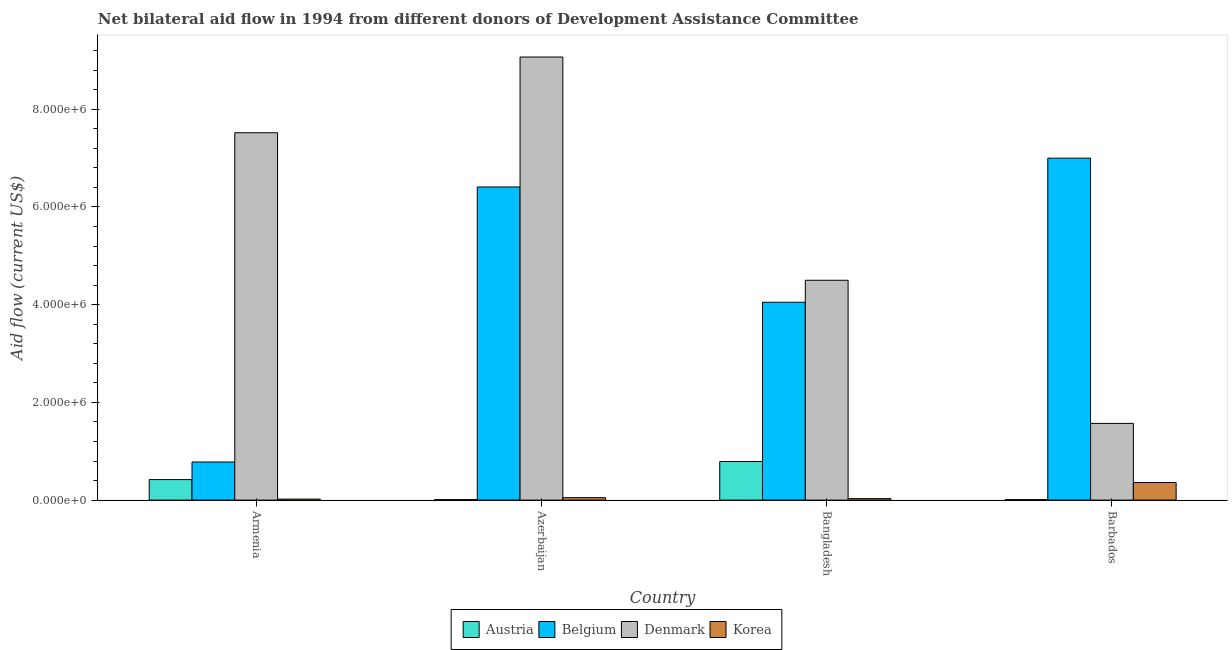How many bars are there on the 4th tick from the left?
Offer a terse response. 4. What is the amount of aid given by denmark in Azerbaijan?
Your response must be concise. 9.07e+06. Across all countries, what is the maximum amount of aid given by belgium?
Your answer should be very brief. 7.00e+06. Across all countries, what is the minimum amount of aid given by belgium?
Provide a succinct answer. 7.80e+05. In which country was the amount of aid given by denmark maximum?
Give a very brief answer. Azerbaijan. In which country was the amount of aid given by korea minimum?
Ensure brevity in your answer.  Armenia. What is the total amount of aid given by korea in the graph?
Keep it short and to the point. 4.60e+05. What is the difference between the amount of aid given by austria in Armenia and that in Azerbaijan?
Your answer should be very brief. 4.10e+05. What is the difference between the amount of aid given by belgium in Bangladesh and the amount of aid given by denmark in Barbados?
Your response must be concise. 2.48e+06. What is the average amount of aid given by denmark per country?
Offer a terse response. 5.66e+06. What is the difference between the amount of aid given by austria and amount of aid given by korea in Bangladesh?
Make the answer very short. 7.60e+05. What is the ratio of the amount of aid given by korea in Azerbaijan to that in Barbados?
Provide a succinct answer. 0.14. Is the amount of aid given by denmark in Armenia less than that in Bangladesh?
Offer a very short reply. No. What is the difference between the highest and the second highest amount of aid given by denmark?
Ensure brevity in your answer.  1.55e+06. What is the difference between the highest and the lowest amount of aid given by belgium?
Your response must be concise. 6.22e+06. In how many countries, is the amount of aid given by korea greater than the average amount of aid given by korea taken over all countries?
Keep it short and to the point. 1. Is the sum of the amount of aid given by denmark in Armenia and Barbados greater than the maximum amount of aid given by belgium across all countries?
Offer a terse response. Yes. Is it the case that in every country, the sum of the amount of aid given by austria and amount of aid given by denmark is greater than the sum of amount of aid given by belgium and amount of aid given by korea?
Keep it short and to the point. Yes. What does the 3rd bar from the left in Azerbaijan represents?
Make the answer very short. Denmark. What does the 1st bar from the right in Azerbaijan represents?
Offer a terse response. Korea. Is it the case that in every country, the sum of the amount of aid given by austria and amount of aid given by belgium is greater than the amount of aid given by denmark?
Offer a terse response. No. How many bars are there?
Your answer should be very brief. 16. Are all the bars in the graph horizontal?
Your answer should be very brief. No. Are the values on the major ticks of Y-axis written in scientific E-notation?
Provide a short and direct response. Yes. Does the graph contain any zero values?
Your response must be concise. No. Where does the legend appear in the graph?
Make the answer very short. Bottom center. How many legend labels are there?
Your answer should be very brief. 4. What is the title of the graph?
Offer a very short reply. Net bilateral aid flow in 1994 from different donors of Development Assistance Committee. What is the label or title of the Y-axis?
Provide a short and direct response. Aid flow (current US$). What is the Aid flow (current US$) in Austria in Armenia?
Offer a very short reply. 4.20e+05. What is the Aid flow (current US$) in Belgium in Armenia?
Offer a very short reply. 7.80e+05. What is the Aid flow (current US$) in Denmark in Armenia?
Give a very brief answer. 7.52e+06. What is the Aid flow (current US$) of Korea in Armenia?
Offer a very short reply. 2.00e+04. What is the Aid flow (current US$) in Belgium in Azerbaijan?
Keep it short and to the point. 6.41e+06. What is the Aid flow (current US$) in Denmark in Azerbaijan?
Provide a short and direct response. 9.07e+06. What is the Aid flow (current US$) of Korea in Azerbaijan?
Your answer should be very brief. 5.00e+04. What is the Aid flow (current US$) of Austria in Bangladesh?
Keep it short and to the point. 7.90e+05. What is the Aid flow (current US$) in Belgium in Bangladesh?
Make the answer very short. 4.05e+06. What is the Aid flow (current US$) of Denmark in Bangladesh?
Provide a succinct answer. 4.50e+06. What is the Aid flow (current US$) in Austria in Barbados?
Offer a terse response. 10000. What is the Aid flow (current US$) in Belgium in Barbados?
Ensure brevity in your answer.  7.00e+06. What is the Aid flow (current US$) of Denmark in Barbados?
Your response must be concise. 1.57e+06. Across all countries, what is the maximum Aid flow (current US$) of Austria?
Provide a succinct answer. 7.90e+05. Across all countries, what is the maximum Aid flow (current US$) in Denmark?
Your answer should be compact. 9.07e+06. Across all countries, what is the minimum Aid flow (current US$) in Belgium?
Ensure brevity in your answer.  7.80e+05. Across all countries, what is the minimum Aid flow (current US$) in Denmark?
Ensure brevity in your answer.  1.57e+06. What is the total Aid flow (current US$) of Austria in the graph?
Ensure brevity in your answer.  1.23e+06. What is the total Aid flow (current US$) of Belgium in the graph?
Your response must be concise. 1.82e+07. What is the total Aid flow (current US$) of Denmark in the graph?
Keep it short and to the point. 2.27e+07. What is the total Aid flow (current US$) in Korea in the graph?
Provide a short and direct response. 4.60e+05. What is the difference between the Aid flow (current US$) in Austria in Armenia and that in Azerbaijan?
Give a very brief answer. 4.10e+05. What is the difference between the Aid flow (current US$) in Belgium in Armenia and that in Azerbaijan?
Keep it short and to the point. -5.63e+06. What is the difference between the Aid flow (current US$) of Denmark in Armenia and that in Azerbaijan?
Give a very brief answer. -1.55e+06. What is the difference between the Aid flow (current US$) of Korea in Armenia and that in Azerbaijan?
Your answer should be very brief. -3.00e+04. What is the difference between the Aid flow (current US$) of Austria in Armenia and that in Bangladesh?
Offer a very short reply. -3.70e+05. What is the difference between the Aid flow (current US$) in Belgium in Armenia and that in Bangladesh?
Provide a succinct answer. -3.27e+06. What is the difference between the Aid flow (current US$) in Denmark in Armenia and that in Bangladesh?
Your answer should be very brief. 3.02e+06. What is the difference between the Aid flow (current US$) of Korea in Armenia and that in Bangladesh?
Your answer should be very brief. -10000. What is the difference between the Aid flow (current US$) in Austria in Armenia and that in Barbados?
Provide a succinct answer. 4.10e+05. What is the difference between the Aid flow (current US$) in Belgium in Armenia and that in Barbados?
Make the answer very short. -6.22e+06. What is the difference between the Aid flow (current US$) of Denmark in Armenia and that in Barbados?
Offer a very short reply. 5.95e+06. What is the difference between the Aid flow (current US$) in Austria in Azerbaijan and that in Bangladesh?
Ensure brevity in your answer.  -7.80e+05. What is the difference between the Aid flow (current US$) in Belgium in Azerbaijan and that in Bangladesh?
Offer a very short reply. 2.36e+06. What is the difference between the Aid flow (current US$) of Denmark in Azerbaijan and that in Bangladesh?
Your answer should be very brief. 4.57e+06. What is the difference between the Aid flow (current US$) of Belgium in Azerbaijan and that in Barbados?
Your answer should be compact. -5.90e+05. What is the difference between the Aid flow (current US$) of Denmark in Azerbaijan and that in Barbados?
Offer a terse response. 7.50e+06. What is the difference between the Aid flow (current US$) of Korea in Azerbaijan and that in Barbados?
Provide a short and direct response. -3.10e+05. What is the difference between the Aid flow (current US$) in Austria in Bangladesh and that in Barbados?
Your answer should be compact. 7.80e+05. What is the difference between the Aid flow (current US$) in Belgium in Bangladesh and that in Barbados?
Ensure brevity in your answer.  -2.95e+06. What is the difference between the Aid flow (current US$) of Denmark in Bangladesh and that in Barbados?
Give a very brief answer. 2.93e+06. What is the difference between the Aid flow (current US$) of Korea in Bangladesh and that in Barbados?
Your answer should be very brief. -3.30e+05. What is the difference between the Aid flow (current US$) in Austria in Armenia and the Aid flow (current US$) in Belgium in Azerbaijan?
Offer a very short reply. -5.99e+06. What is the difference between the Aid flow (current US$) in Austria in Armenia and the Aid flow (current US$) in Denmark in Azerbaijan?
Give a very brief answer. -8.65e+06. What is the difference between the Aid flow (current US$) in Belgium in Armenia and the Aid flow (current US$) in Denmark in Azerbaijan?
Provide a succinct answer. -8.29e+06. What is the difference between the Aid flow (current US$) in Belgium in Armenia and the Aid flow (current US$) in Korea in Azerbaijan?
Your response must be concise. 7.30e+05. What is the difference between the Aid flow (current US$) in Denmark in Armenia and the Aid flow (current US$) in Korea in Azerbaijan?
Provide a succinct answer. 7.47e+06. What is the difference between the Aid flow (current US$) in Austria in Armenia and the Aid flow (current US$) in Belgium in Bangladesh?
Provide a short and direct response. -3.63e+06. What is the difference between the Aid flow (current US$) of Austria in Armenia and the Aid flow (current US$) of Denmark in Bangladesh?
Provide a short and direct response. -4.08e+06. What is the difference between the Aid flow (current US$) of Belgium in Armenia and the Aid flow (current US$) of Denmark in Bangladesh?
Your answer should be compact. -3.72e+06. What is the difference between the Aid flow (current US$) of Belgium in Armenia and the Aid flow (current US$) of Korea in Bangladesh?
Offer a terse response. 7.50e+05. What is the difference between the Aid flow (current US$) of Denmark in Armenia and the Aid flow (current US$) of Korea in Bangladesh?
Make the answer very short. 7.49e+06. What is the difference between the Aid flow (current US$) of Austria in Armenia and the Aid flow (current US$) of Belgium in Barbados?
Provide a succinct answer. -6.58e+06. What is the difference between the Aid flow (current US$) of Austria in Armenia and the Aid flow (current US$) of Denmark in Barbados?
Your answer should be very brief. -1.15e+06. What is the difference between the Aid flow (current US$) in Austria in Armenia and the Aid flow (current US$) in Korea in Barbados?
Your answer should be compact. 6.00e+04. What is the difference between the Aid flow (current US$) in Belgium in Armenia and the Aid flow (current US$) in Denmark in Barbados?
Provide a succinct answer. -7.90e+05. What is the difference between the Aid flow (current US$) of Denmark in Armenia and the Aid flow (current US$) of Korea in Barbados?
Make the answer very short. 7.16e+06. What is the difference between the Aid flow (current US$) in Austria in Azerbaijan and the Aid flow (current US$) in Belgium in Bangladesh?
Give a very brief answer. -4.04e+06. What is the difference between the Aid flow (current US$) in Austria in Azerbaijan and the Aid flow (current US$) in Denmark in Bangladesh?
Provide a succinct answer. -4.49e+06. What is the difference between the Aid flow (current US$) in Austria in Azerbaijan and the Aid flow (current US$) in Korea in Bangladesh?
Offer a very short reply. -2.00e+04. What is the difference between the Aid flow (current US$) of Belgium in Azerbaijan and the Aid flow (current US$) of Denmark in Bangladesh?
Your response must be concise. 1.91e+06. What is the difference between the Aid flow (current US$) in Belgium in Azerbaijan and the Aid flow (current US$) in Korea in Bangladesh?
Provide a short and direct response. 6.38e+06. What is the difference between the Aid flow (current US$) in Denmark in Azerbaijan and the Aid flow (current US$) in Korea in Bangladesh?
Give a very brief answer. 9.04e+06. What is the difference between the Aid flow (current US$) in Austria in Azerbaijan and the Aid flow (current US$) in Belgium in Barbados?
Offer a very short reply. -6.99e+06. What is the difference between the Aid flow (current US$) in Austria in Azerbaijan and the Aid flow (current US$) in Denmark in Barbados?
Your answer should be compact. -1.56e+06. What is the difference between the Aid flow (current US$) in Austria in Azerbaijan and the Aid flow (current US$) in Korea in Barbados?
Give a very brief answer. -3.50e+05. What is the difference between the Aid flow (current US$) of Belgium in Azerbaijan and the Aid flow (current US$) of Denmark in Barbados?
Your answer should be compact. 4.84e+06. What is the difference between the Aid flow (current US$) in Belgium in Azerbaijan and the Aid flow (current US$) in Korea in Barbados?
Your answer should be compact. 6.05e+06. What is the difference between the Aid flow (current US$) in Denmark in Azerbaijan and the Aid flow (current US$) in Korea in Barbados?
Provide a short and direct response. 8.71e+06. What is the difference between the Aid flow (current US$) in Austria in Bangladesh and the Aid flow (current US$) in Belgium in Barbados?
Make the answer very short. -6.21e+06. What is the difference between the Aid flow (current US$) in Austria in Bangladesh and the Aid flow (current US$) in Denmark in Barbados?
Keep it short and to the point. -7.80e+05. What is the difference between the Aid flow (current US$) in Austria in Bangladesh and the Aid flow (current US$) in Korea in Barbados?
Your answer should be very brief. 4.30e+05. What is the difference between the Aid flow (current US$) in Belgium in Bangladesh and the Aid flow (current US$) in Denmark in Barbados?
Offer a terse response. 2.48e+06. What is the difference between the Aid flow (current US$) of Belgium in Bangladesh and the Aid flow (current US$) of Korea in Barbados?
Your answer should be compact. 3.69e+06. What is the difference between the Aid flow (current US$) of Denmark in Bangladesh and the Aid flow (current US$) of Korea in Barbados?
Your answer should be very brief. 4.14e+06. What is the average Aid flow (current US$) in Austria per country?
Your answer should be compact. 3.08e+05. What is the average Aid flow (current US$) in Belgium per country?
Keep it short and to the point. 4.56e+06. What is the average Aid flow (current US$) in Denmark per country?
Provide a succinct answer. 5.66e+06. What is the average Aid flow (current US$) in Korea per country?
Your answer should be compact. 1.15e+05. What is the difference between the Aid flow (current US$) in Austria and Aid flow (current US$) in Belgium in Armenia?
Keep it short and to the point. -3.60e+05. What is the difference between the Aid flow (current US$) in Austria and Aid flow (current US$) in Denmark in Armenia?
Your response must be concise. -7.10e+06. What is the difference between the Aid flow (current US$) of Austria and Aid flow (current US$) of Korea in Armenia?
Make the answer very short. 4.00e+05. What is the difference between the Aid flow (current US$) in Belgium and Aid flow (current US$) in Denmark in Armenia?
Keep it short and to the point. -6.74e+06. What is the difference between the Aid flow (current US$) of Belgium and Aid flow (current US$) of Korea in Armenia?
Ensure brevity in your answer.  7.60e+05. What is the difference between the Aid flow (current US$) in Denmark and Aid flow (current US$) in Korea in Armenia?
Your answer should be compact. 7.50e+06. What is the difference between the Aid flow (current US$) in Austria and Aid flow (current US$) in Belgium in Azerbaijan?
Your response must be concise. -6.40e+06. What is the difference between the Aid flow (current US$) of Austria and Aid flow (current US$) of Denmark in Azerbaijan?
Offer a very short reply. -9.06e+06. What is the difference between the Aid flow (current US$) in Belgium and Aid flow (current US$) in Denmark in Azerbaijan?
Give a very brief answer. -2.66e+06. What is the difference between the Aid flow (current US$) of Belgium and Aid flow (current US$) of Korea in Azerbaijan?
Provide a short and direct response. 6.36e+06. What is the difference between the Aid flow (current US$) in Denmark and Aid flow (current US$) in Korea in Azerbaijan?
Offer a terse response. 9.02e+06. What is the difference between the Aid flow (current US$) in Austria and Aid flow (current US$) in Belgium in Bangladesh?
Offer a very short reply. -3.26e+06. What is the difference between the Aid flow (current US$) in Austria and Aid flow (current US$) in Denmark in Bangladesh?
Offer a terse response. -3.71e+06. What is the difference between the Aid flow (current US$) in Austria and Aid flow (current US$) in Korea in Bangladesh?
Make the answer very short. 7.60e+05. What is the difference between the Aid flow (current US$) in Belgium and Aid flow (current US$) in Denmark in Bangladesh?
Offer a terse response. -4.50e+05. What is the difference between the Aid flow (current US$) of Belgium and Aid flow (current US$) of Korea in Bangladesh?
Give a very brief answer. 4.02e+06. What is the difference between the Aid flow (current US$) of Denmark and Aid flow (current US$) of Korea in Bangladesh?
Offer a terse response. 4.47e+06. What is the difference between the Aid flow (current US$) of Austria and Aid flow (current US$) of Belgium in Barbados?
Your answer should be very brief. -6.99e+06. What is the difference between the Aid flow (current US$) in Austria and Aid flow (current US$) in Denmark in Barbados?
Give a very brief answer. -1.56e+06. What is the difference between the Aid flow (current US$) in Austria and Aid flow (current US$) in Korea in Barbados?
Your answer should be compact. -3.50e+05. What is the difference between the Aid flow (current US$) in Belgium and Aid flow (current US$) in Denmark in Barbados?
Provide a succinct answer. 5.43e+06. What is the difference between the Aid flow (current US$) of Belgium and Aid flow (current US$) of Korea in Barbados?
Offer a terse response. 6.64e+06. What is the difference between the Aid flow (current US$) of Denmark and Aid flow (current US$) of Korea in Barbados?
Your answer should be very brief. 1.21e+06. What is the ratio of the Aid flow (current US$) of Austria in Armenia to that in Azerbaijan?
Provide a short and direct response. 42. What is the ratio of the Aid flow (current US$) of Belgium in Armenia to that in Azerbaijan?
Offer a terse response. 0.12. What is the ratio of the Aid flow (current US$) of Denmark in Armenia to that in Azerbaijan?
Keep it short and to the point. 0.83. What is the ratio of the Aid flow (current US$) in Korea in Armenia to that in Azerbaijan?
Your answer should be compact. 0.4. What is the ratio of the Aid flow (current US$) in Austria in Armenia to that in Bangladesh?
Offer a very short reply. 0.53. What is the ratio of the Aid flow (current US$) of Belgium in Armenia to that in Bangladesh?
Your response must be concise. 0.19. What is the ratio of the Aid flow (current US$) of Denmark in Armenia to that in Bangladesh?
Provide a succinct answer. 1.67. What is the ratio of the Aid flow (current US$) in Korea in Armenia to that in Bangladesh?
Your response must be concise. 0.67. What is the ratio of the Aid flow (current US$) of Belgium in Armenia to that in Barbados?
Your answer should be compact. 0.11. What is the ratio of the Aid flow (current US$) of Denmark in Armenia to that in Barbados?
Your response must be concise. 4.79. What is the ratio of the Aid flow (current US$) in Korea in Armenia to that in Barbados?
Make the answer very short. 0.06. What is the ratio of the Aid flow (current US$) of Austria in Azerbaijan to that in Bangladesh?
Keep it short and to the point. 0.01. What is the ratio of the Aid flow (current US$) of Belgium in Azerbaijan to that in Bangladesh?
Keep it short and to the point. 1.58. What is the ratio of the Aid flow (current US$) of Denmark in Azerbaijan to that in Bangladesh?
Ensure brevity in your answer.  2.02. What is the ratio of the Aid flow (current US$) in Austria in Azerbaijan to that in Barbados?
Offer a very short reply. 1. What is the ratio of the Aid flow (current US$) of Belgium in Azerbaijan to that in Barbados?
Offer a terse response. 0.92. What is the ratio of the Aid flow (current US$) in Denmark in Azerbaijan to that in Barbados?
Your answer should be compact. 5.78. What is the ratio of the Aid flow (current US$) in Korea in Azerbaijan to that in Barbados?
Offer a terse response. 0.14. What is the ratio of the Aid flow (current US$) of Austria in Bangladesh to that in Barbados?
Provide a short and direct response. 79. What is the ratio of the Aid flow (current US$) of Belgium in Bangladesh to that in Barbados?
Your response must be concise. 0.58. What is the ratio of the Aid flow (current US$) in Denmark in Bangladesh to that in Barbados?
Your answer should be compact. 2.87. What is the ratio of the Aid flow (current US$) in Korea in Bangladesh to that in Barbados?
Your answer should be compact. 0.08. What is the difference between the highest and the second highest Aid flow (current US$) of Austria?
Your response must be concise. 3.70e+05. What is the difference between the highest and the second highest Aid flow (current US$) of Belgium?
Provide a short and direct response. 5.90e+05. What is the difference between the highest and the second highest Aid flow (current US$) of Denmark?
Ensure brevity in your answer.  1.55e+06. What is the difference between the highest and the second highest Aid flow (current US$) in Korea?
Offer a terse response. 3.10e+05. What is the difference between the highest and the lowest Aid flow (current US$) in Austria?
Provide a short and direct response. 7.80e+05. What is the difference between the highest and the lowest Aid flow (current US$) in Belgium?
Your response must be concise. 6.22e+06. What is the difference between the highest and the lowest Aid flow (current US$) of Denmark?
Offer a terse response. 7.50e+06. What is the difference between the highest and the lowest Aid flow (current US$) of Korea?
Provide a short and direct response. 3.40e+05. 